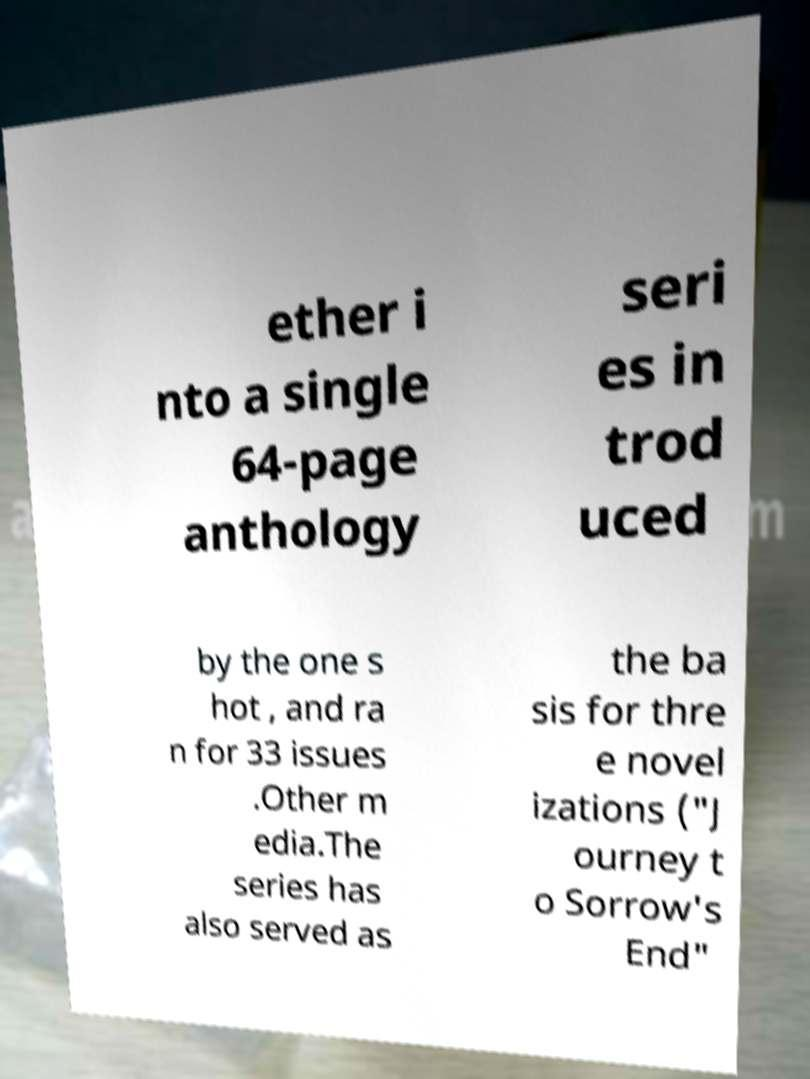I need the written content from this picture converted into text. Can you do that? ether i nto a single 64-page anthology seri es in trod uced by the one s hot , and ra n for 33 issues .Other m edia.The series has also served as the ba sis for thre e novel izations ("J ourney t o Sorrow's End" 